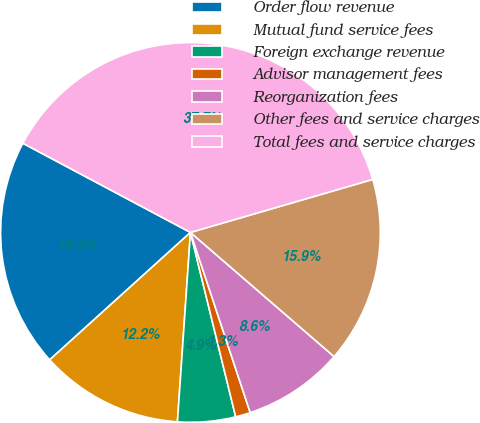<chart> <loc_0><loc_0><loc_500><loc_500><pie_chart><fcel>Order flow revenue<fcel>Mutual fund service fees<fcel>Foreign exchange revenue<fcel>Advisor management fees<fcel>Reorganization fees<fcel>Other fees and service charges<fcel>Total fees and service charges<nl><fcel>19.49%<fcel>12.2%<fcel>4.92%<fcel>1.27%<fcel>8.56%<fcel>15.85%<fcel>37.71%<nl></chart> 